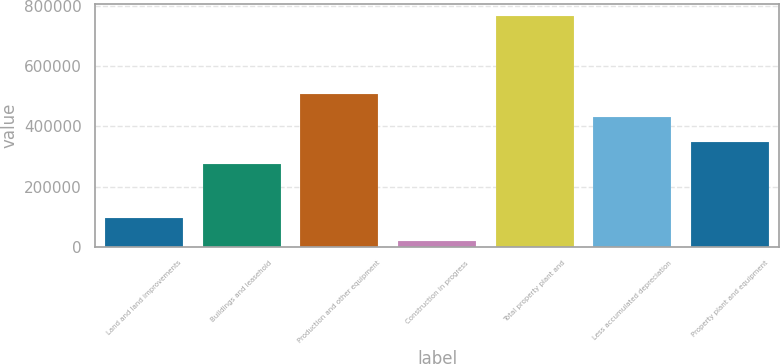Convert chart. <chart><loc_0><loc_0><loc_500><loc_500><bar_chart><fcel>Land and land improvements<fcel>Buildings and leasehold<fcel>Production and other equipment<fcel>Construction in progress<fcel>Total property plant and<fcel>Less accumulated depreciation<fcel>Property plant and equipment<nl><fcel>95038.5<fcel>274021<fcel>506266<fcel>20204<fcel>768549<fcel>431431<fcel>348856<nl></chart> 